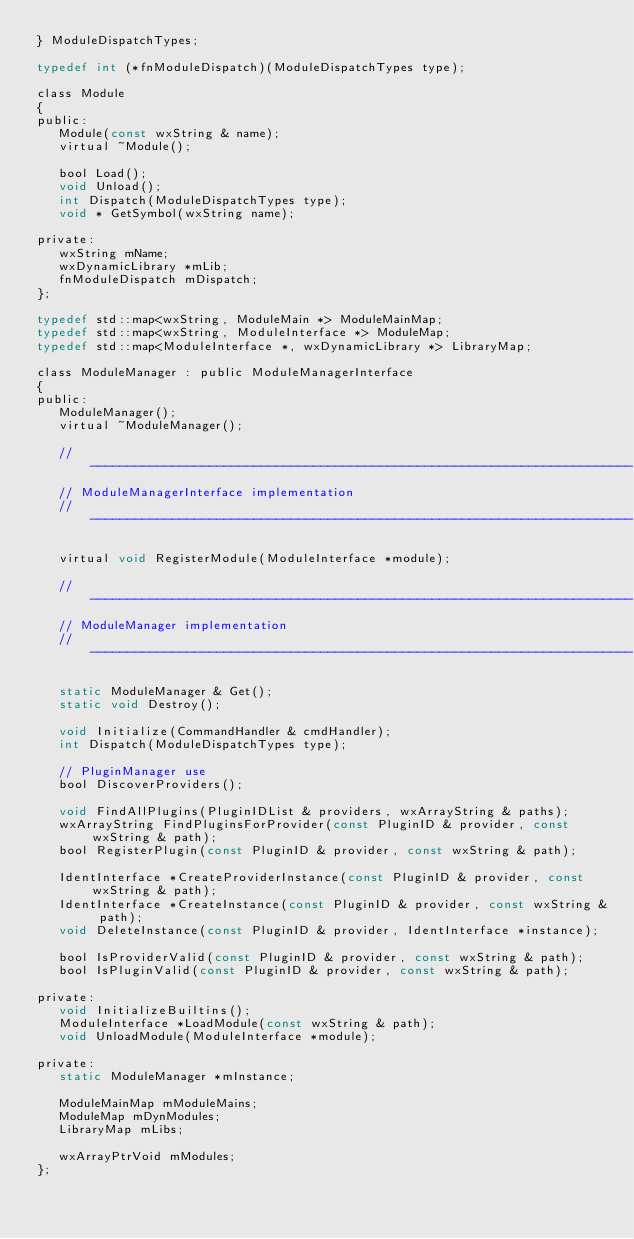<code> <loc_0><loc_0><loc_500><loc_500><_C_>} ModuleDispatchTypes;

typedef int (*fnModuleDispatch)(ModuleDispatchTypes type);

class Module
{
public:
   Module(const wxString & name);
   virtual ~Module();

   bool Load();
   void Unload();
   int Dispatch(ModuleDispatchTypes type);
   void * GetSymbol(wxString name);

private:
   wxString mName;
   wxDynamicLibrary *mLib;
   fnModuleDispatch mDispatch;
};

typedef std::map<wxString, ModuleMain *> ModuleMainMap;
typedef std::map<wxString, ModuleInterface *> ModuleMap;
typedef std::map<ModuleInterface *, wxDynamicLibrary *> LibraryMap;

class ModuleManager : public ModuleManagerInterface
{
public:
   ModuleManager();
   virtual ~ModuleManager();

   // -------------------------------------------------------------------------
   // ModuleManagerInterface implementation
   // -------------------------------------------------------------------------

   virtual void RegisterModule(ModuleInterface *module);

   // -------------------------------------------------------------------------
   // ModuleManager implementation
   // -------------------------------------------------------------------------

   static ModuleManager & Get();
   static void Destroy();

   void Initialize(CommandHandler & cmdHandler);
   int Dispatch(ModuleDispatchTypes type);

   // PluginManager use
   bool DiscoverProviders();

   void FindAllPlugins(PluginIDList & providers, wxArrayString & paths);
   wxArrayString FindPluginsForProvider(const PluginID & provider, const wxString & path);
   bool RegisterPlugin(const PluginID & provider, const wxString & path);

   IdentInterface *CreateProviderInstance(const PluginID & provider, const wxString & path);
   IdentInterface *CreateInstance(const PluginID & provider, const wxString & path);
   void DeleteInstance(const PluginID & provider, IdentInterface *instance);

   bool IsProviderValid(const PluginID & provider, const wxString & path);
   bool IsPluginValid(const PluginID & provider, const wxString & path);

private:
   void InitializeBuiltins();
   ModuleInterface *LoadModule(const wxString & path);
   void UnloadModule(ModuleInterface *module);

private:
   static ModuleManager *mInstance;

   ModuleMainMap mModuleMains;
   ModuleMap mDynModules;
   LibraryMap mLibs;

   wxArrayPtrVoid mModules;
};
</code> 